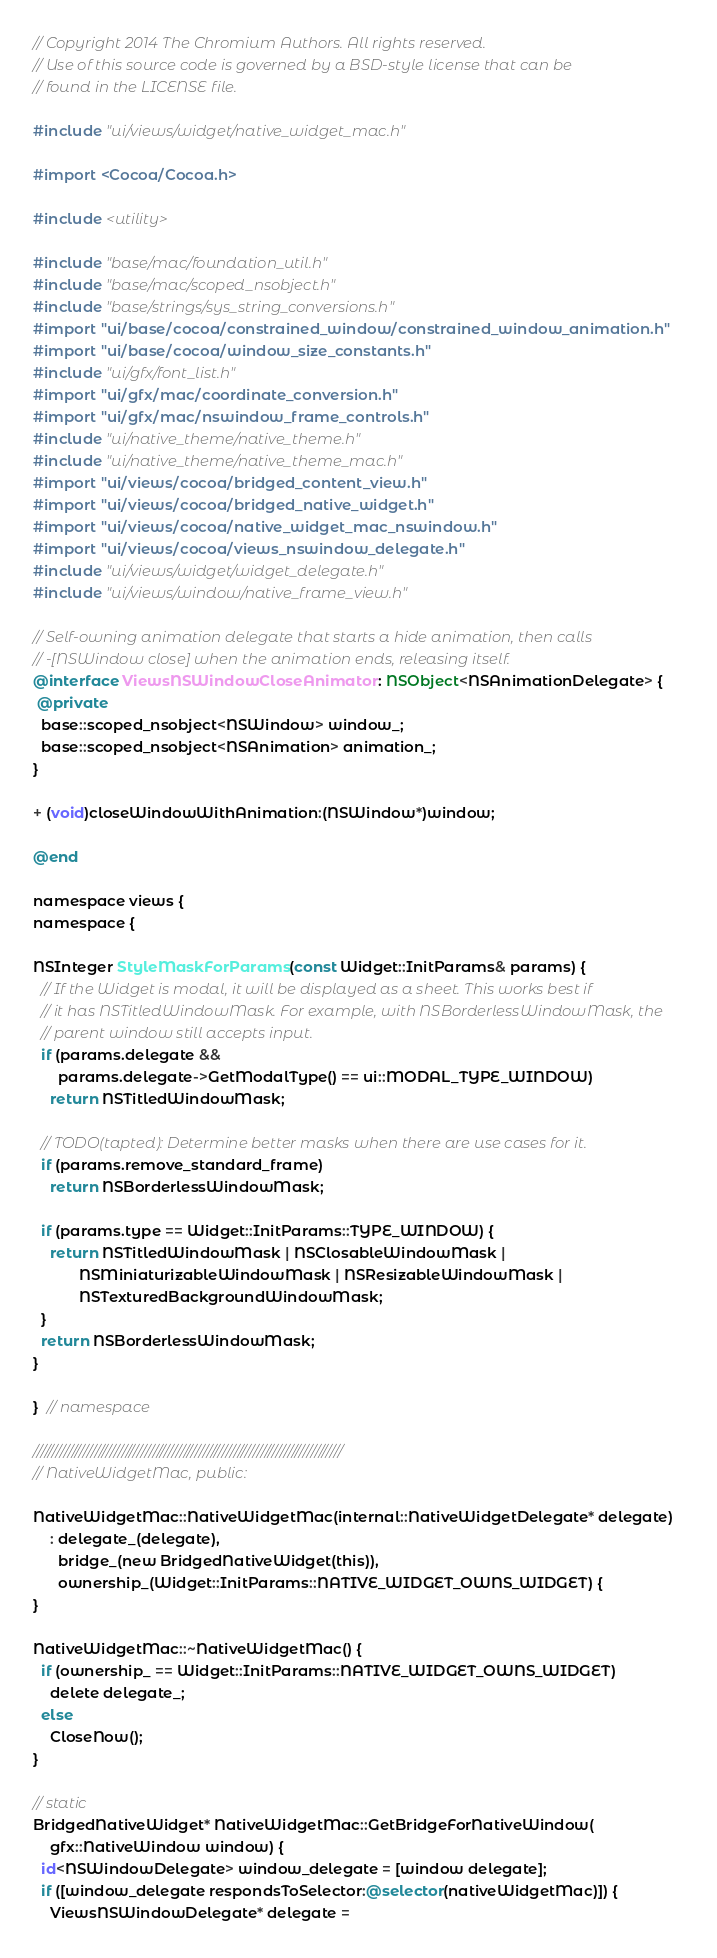Convert code to text. <code><loc_0><loc_0><loc_500><loc_500><_ObjectiveC_>// Copyright 2014 The Chromium Authors. All rights reserved.
// Use of this source code is governed by a BSD-style license that can be
// found in the LICENSE file.

#include "ui/views/widget/native_widget_mac.h"

#import <Cocoa/Cocoa.h>

#include <utility>

#include "base/mac/foundation_util.h"
#include "base/mac/scoped_nsobject.h"
#include "base/strings/sys_string_conversions.h"
#import "ui/base/cocoa/constrained_window/constrained_window_animation.h"
#import "ui/base/cocoa/window_size_constants.h"
#include "ui/gfx/font_list.h"
#import "ui/gfx/mac/coordinate_conversion.h"
#import "ui/gfx/mac/nswindow_frame_controls.h"
#include "ui/native_theme/native_theme.h"
#include "ui/native_theme/native_theme_mac.h"
#import "ui/views/cocoa/bridged_content_view.h"
#import "ui/views/cocoa/bridged_native_widget.h"
#import "ui/views/cocoa/native_widget_mac_nswindow.h"
#import "ui/views/cocoa/views_nswindow_delegate.h"
#include "ui/views/widget/widget_delegate.h"
#include "ui/views/window/native_frame_view.h"

// Self-owning animation delegate that starts a hide animation, then calls
// -[NSWindow close] when the animation ends, releasing itself.
@interface ViewsNSWindowCloseAnimator : NSObject<NSAnimationDelegate> {
 @private
  base::scoped_nsobject<NSWindow> window_;
  base::scoped_nsobject<NSAnimation> animation_;
}

+ (void)closeWindowWithAnimation:(NSWindow*)window;

@end

namespace views {
namespace {

NSInteger StyleMaskForParams(const Widget::InitParams& params) {
  // If the Widget is modal, it will be displayed as a sheet. This works best if
  // it has NSTitledWindowMask. For example, with NSBorderlessWindowMask, the
  // parent window still accepts input.
  if (params.delegate &&
      params.delegate->GetModalType() == ui::MODAL_TYPE_WINDOW)
    return NSTitledWindowMask;

  // TODO(tapted): Determine better masks when there are use cases for it.
  if (params.remove_standard_frame)
    return NSBorderlessWindowMask;

  if (params.type == Widget::InitParams::TYPE_WINDOW) {
    return NSTitledWindowMask | NSClosableWindowMask |
           NSMiniaturizableWindowMask | NSResizableWindowMask |
           NSTexturedBackgroundWindowMask;
  }
  return NSBorderlessWindowMask;
}

}  // namespace

////////////////////////////////////////////////////////////////////////////////
// NativeWidgetMac, public:

NativeWidgetMac::NativeWidgetMac(internal::NativeWidgetDelegate* delegate)
    : delegate_(delegate),
      bridge_(new BridgedNativeWidget(this)),
      ownership_(Widget::InitParams::NATIVE_WIDGET_OWNS_WIDGET) {
}

NativeWidgetMac::~NativeWidgetMac() {
  if (ownership_ == Widget::InitParams::NATIVE_WIDGET_OWNS_WIDGET)
    delete delegate_;
  else
    CloseNow();
}

// static
BridgedNativeWidget* NativeWidgetMac::GetBridgeForNativeWindow(
    gfx::NativeWindow window) {
  id<NSWindowDelegate> window_delegate = [window delegate];
  if ([window_delegate respondsToSelector:@selector(nativeWidgetMac)]) {
    ViewsNSWindowDelegate* delegate =</code> 